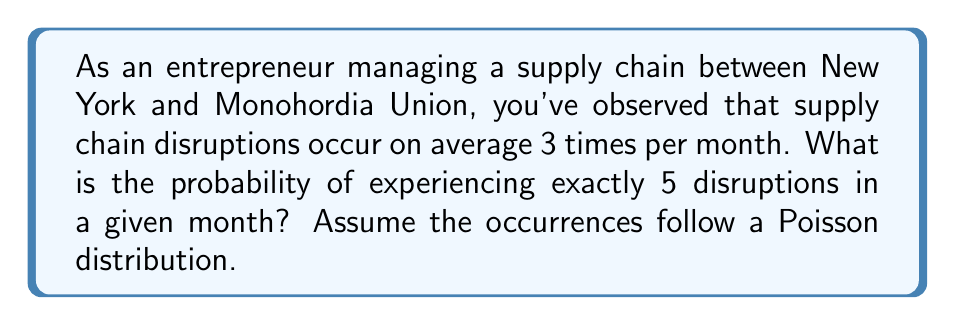Can you answer this question? To solve this problem, we'll use the Poisson distribution formula:

$$P(X = k) = \frac{e^{-\lambda} \lambda^k}{k!}$$

Where:
- $\lambda$ is the average number of events in the given time period
- $k$ is the number of events we're calculating the probability for
- $e$ is Euler's number (approximately 2.71828)

Given:
- $\lambda = 3$ (average 3 disruptions per month)
- $k = 5$ (we're calculating the probability of exactly 5 disruptions)

Step 1: Plug the values into the formula
$$P(X = 5) = \frac{e^{-3} 3^5}{5!}$$

Step 2: Calculate $3^5$
$$3^5 = 243$$

Step 3: Calculate $5!$
$$5! = 5 \times 4 \times 3 \times 2 \times 1 = 120$$

Step 4: Calculate $e^{-3}$
$$e^{-3} \approx 0.0497871$$

Step 5: Put it all together and calculate
$$P(X = 5) = \frac{0.0497871 \times 243}{120} \approx 0.1008$$

Step 6: Convert to a percentage
$$0.1008 \times 100\% = 10.08\%$$
Answer: 10.08% 